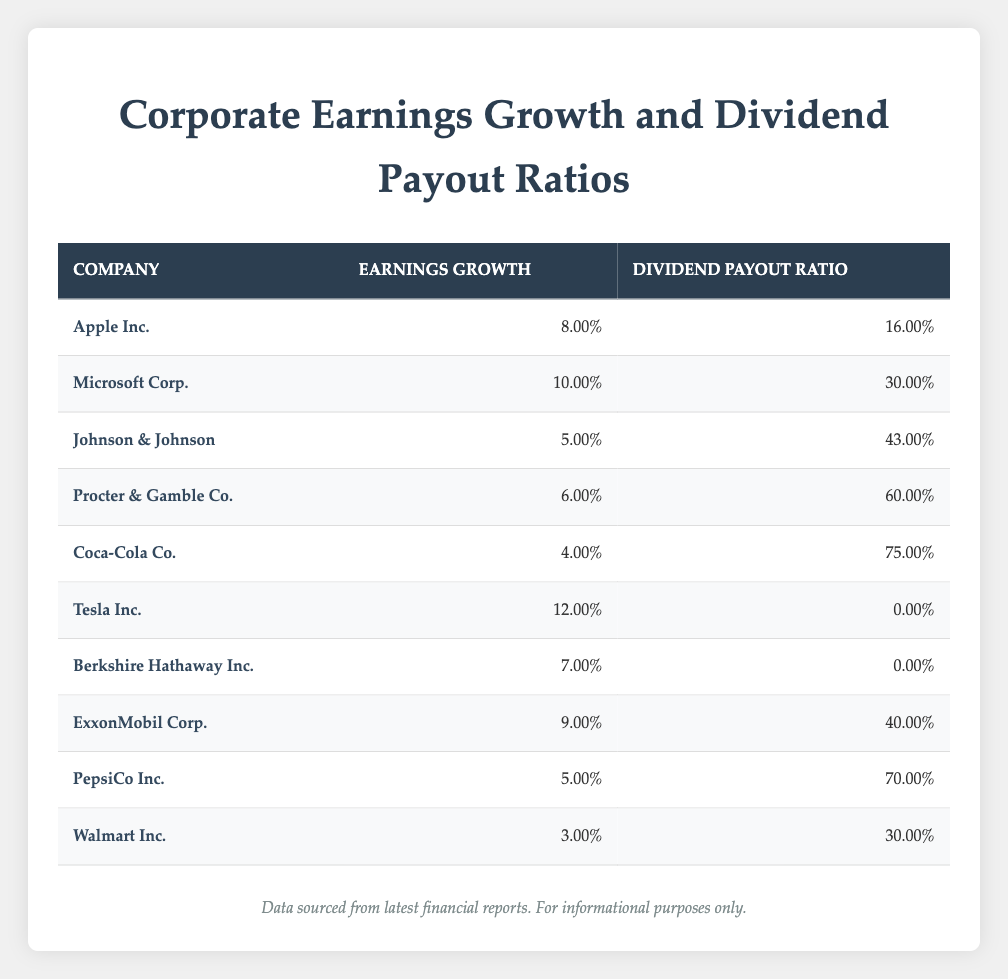What is the earnings growth of Microsoft Corp.? From the table, locating Microsoft Corp. in the first column allows us to see the corresponding earnings growth value in the second column, which is listed as 10.00%.
Answer: 10.00% Which company has the highest dividend payout ratio? By comparing all values in the third column for each company, we find Coca-Cola Co. has the highest dividend payout ratio at 75.00%.
Answer: Coca-Cola Co What is the average earnings growth of all companies listed? To find the average, we add up all the earnings growth values: (0.08 + 0.10 + 0.05 + 0.06 + 0.04 + 0.12 + 0.07 + 0.09 + 0.05 + 0.03) = 0.69. We then divide by the total number of companies, which is 10: 0.69/10 = 0.069 or 6.90%.
Answer: 6.90% Is Procter & Gamble Co. paying more than half of its earnings as dividends? The dividend payout ratio for Procter & Gamble Co. is listed as 60.00%. Since 60.00% is more than 50.00%, we conclude that it is true.
Answer: Yes Which company has the lowest earnings growth and what is its value? Looking through the earnings growth column, we see Walmart Inc. has the lowest earnings growth at 3.00%.
Answer: Walmart Inc. - 3.00% 